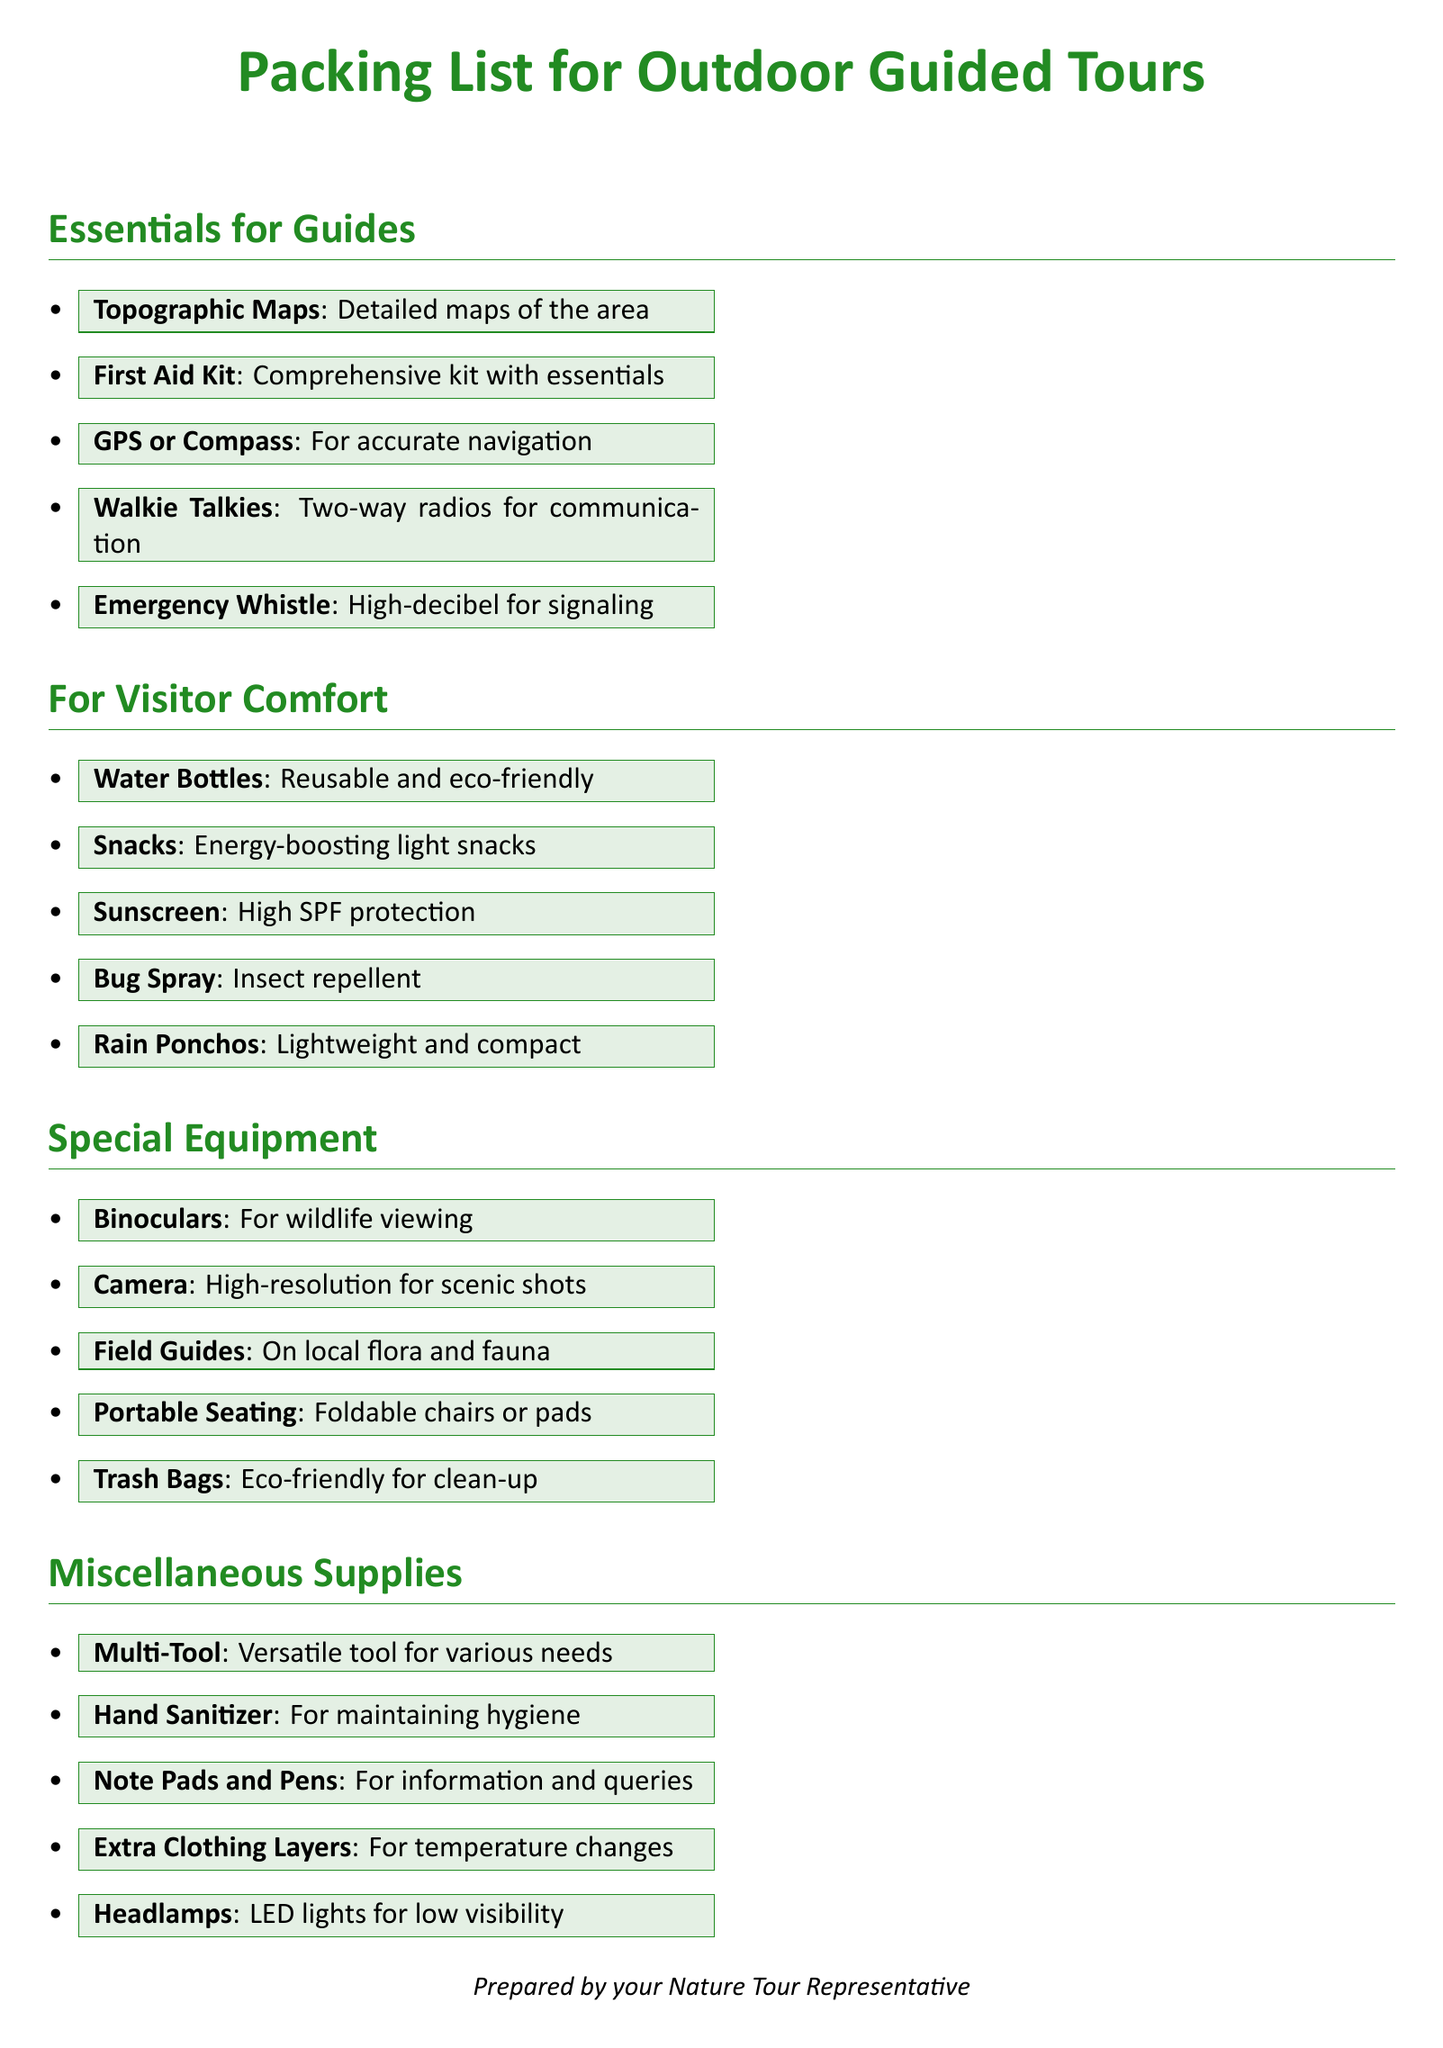What items are necessary for guides? The document lists key items that guides need for outdoor tours, including maps, first aid kits, and communication tools.
Answer: Topographic Maps, First Aid Kit, GPS or Compass, Walkie Talkies, Emergency Whistle What should be included for visitor comfort? The document specifies essential supplies to ensure the comfort of visitors during outdoor tours, such as water bottles and snacks.
Answer: Water Bottles, Snacks, Sunscreen, Bug Spray, Rain Ponchos How many types of 'Special Equipment' are mentioned? The document lists five items classified as special equipment useful for enhancing outdoor experiences, like binoculars and cameras.
Answer: Five What is the purpose of carrying 'Trash Bags'? The document indicates that trash bags are used to keep the environment clean during the tours, which is a key aspect of responsible outdoor management.
Answer: Eco-friendly for clean-up What should be carried for maintaining hygiene? The document emphasizes the importance of hygiene during outdoor tours and states that hand sanitizer is essential for this purpose.
Answer: Hand Sanitizer 